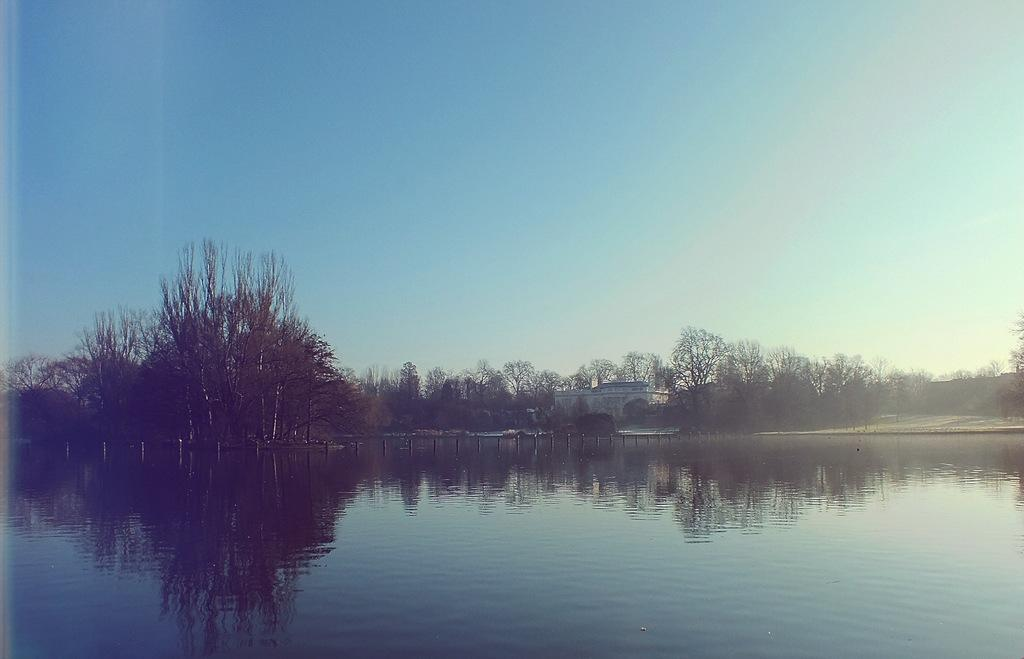What can be seen in the water in the image? There are poles in the water. What is visible in the background of the image? There are trees and a house in the background of the image. What type of face can be seen on the seashore in the image? There is no face or seashore present in the image; it features poles in the water and trees and a house in the background. 